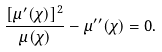Convert formula to latex. <formula><loc_0><loc_0><loc_500><loc_500>\frac { [ \mu ^ { \prime } ( \chi ) ] ^ { 2 } } { \mu ( \chi ) } - \mu ^ { \prime \prime } ( \chi ) = 0 .</formula> 